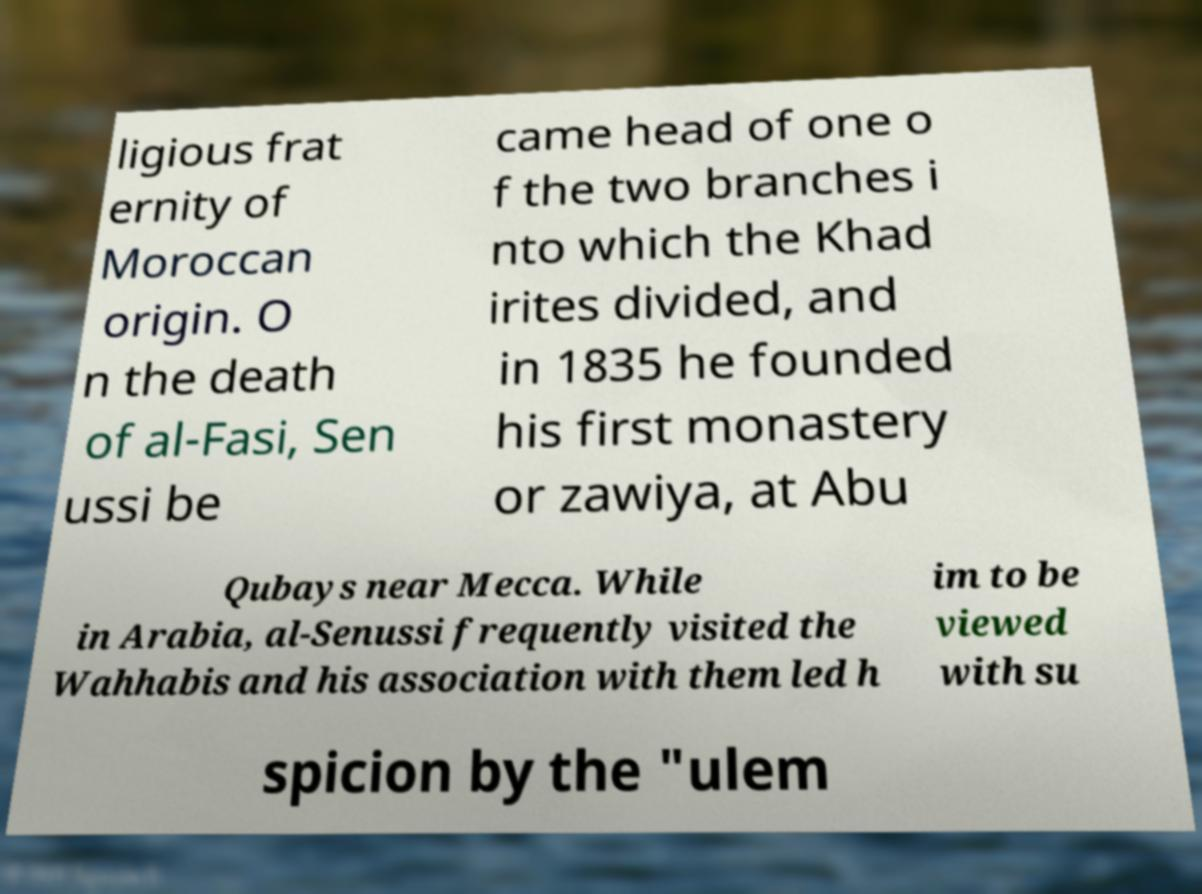Could you extract and type out the text from this image? ligious frat ernity of Moroccan origin. O n the death of al-Fasi, Sen ussi be came head of one o f the two branches i nto which the Khad irites divided, and in 1835 he founded his first monastery or zawiya, at Abu Qubays near Mecca. While in Arabia, al-Senussi frequently visited the Wahhabis and his association with them led h im to be viewed with su spicion by the "ulem 